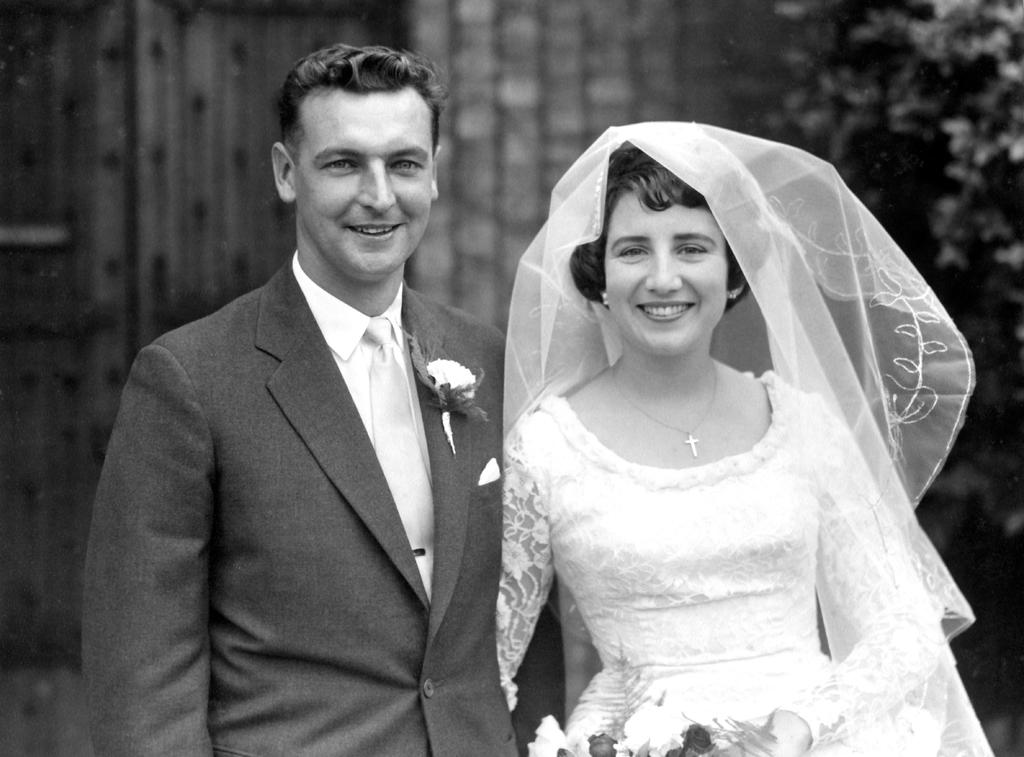Who are the people in the image? There is a man and a woman in the image. What are the man and woman doing in the image? The man and woman are standing and smiling. What are the man and woman wearing in the image? The man and woman are wearing wedding dresses. What can be seen in the background of the image? There is a wall and a tree visible in the background of the image. What type of wilderness can be seen in the image? There is no wilderness present in the image; it features a man and a woman in wedding dresses standing in front of a wall and a tree. 